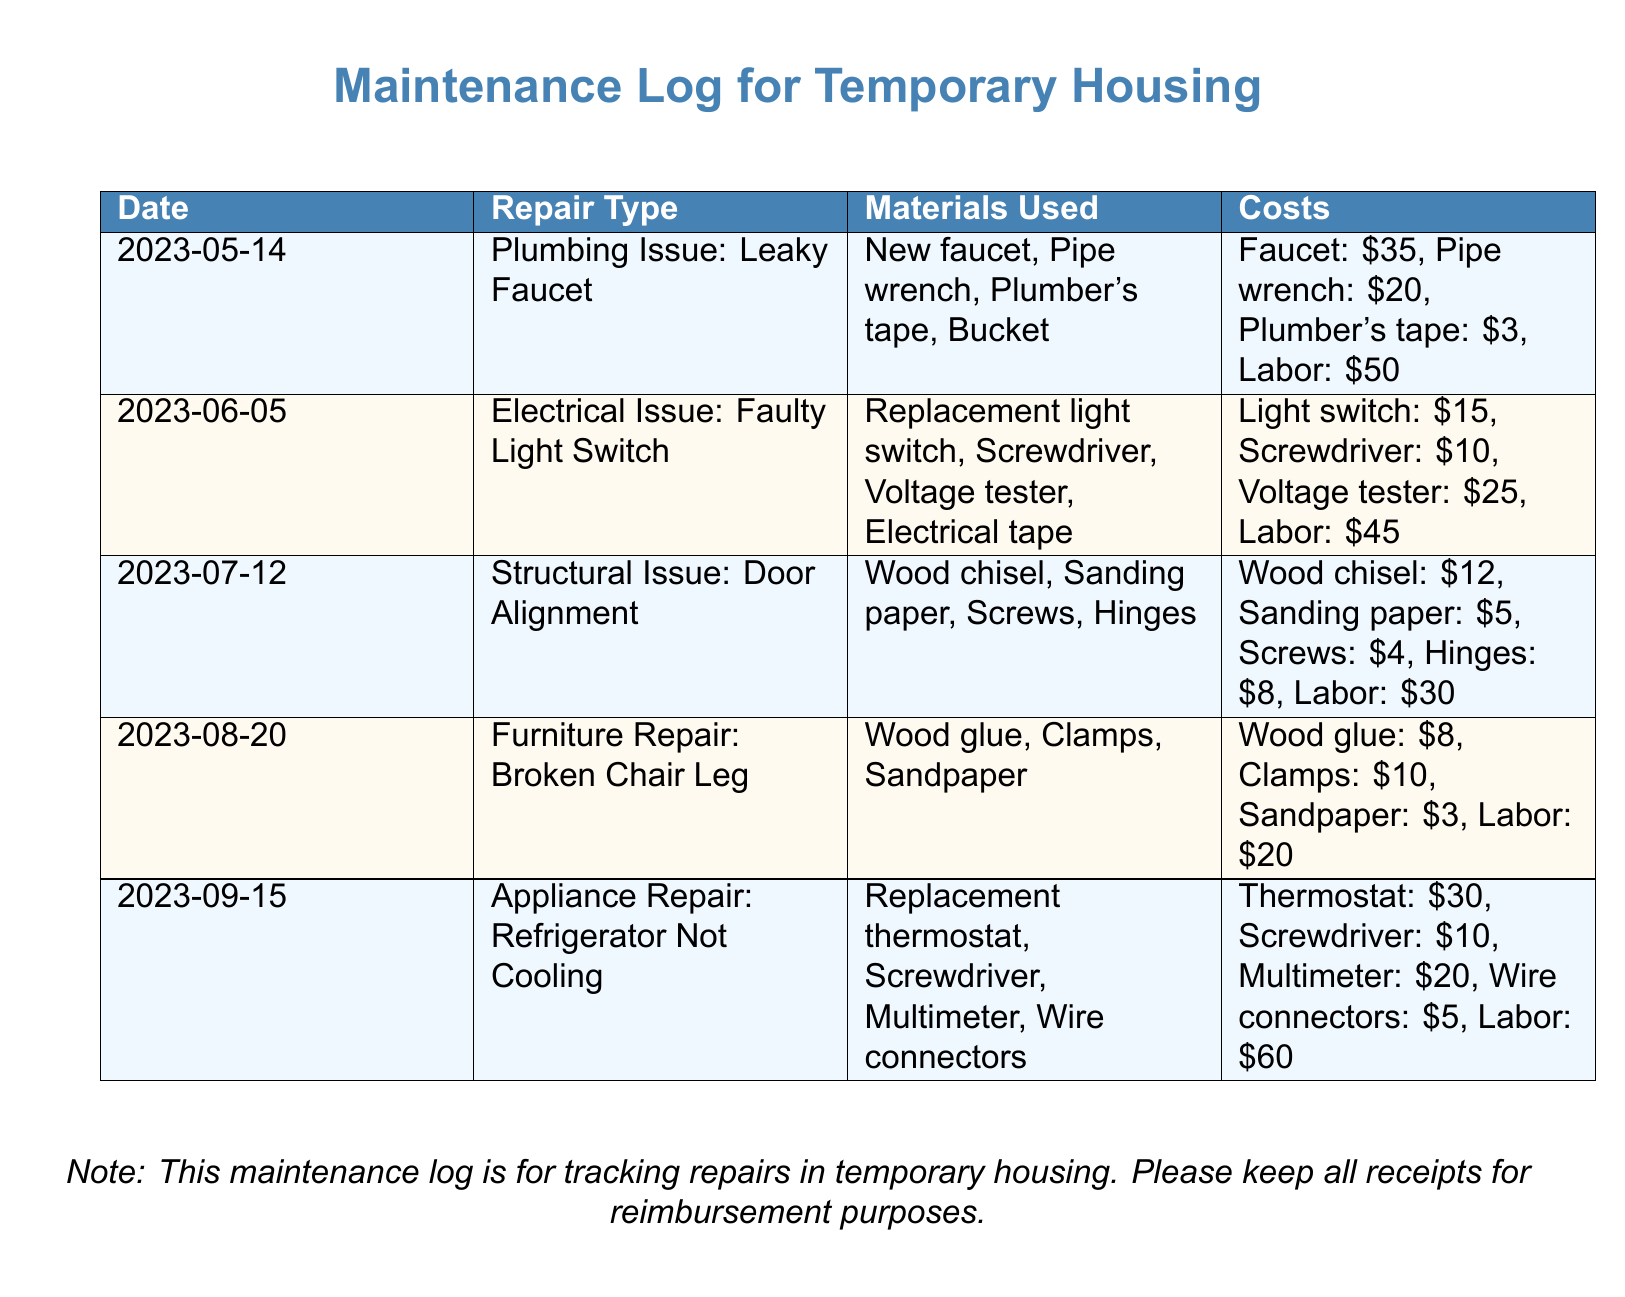What is the date of the plumbing repair? The date of the plumbing repair is listed in the document under the "Date" column, which shows "2023-05-14".
Answer: 2023-05-14 What is the repair type for the entry on June 5, 2023? The entry dated June 5, 2023, corresponds to "Electrical Issue: Faulty Light Switch" in the document.
Answer: Electrical Issue: Faulty Light Switch How much did the replacement thermostat cost? The document lists the cost for the thermostat in the "Costs" column under appliance repair, which is "$30".
Answer: $30 What materials were used for the furniture repair? The "Materials Used" column for the broken chair leg lists "Wood glue, Clamps, Sandpaper" as the materials used.
Answer: Wood glue, Clamps, Sandpaper What is the total cost of the structural issue repair on July 12, 2023? To find the total cost, we look under the "Costs" column for that date, which includes all materials and labor amounting to "$59".
Answer: $59 Which repair type had the highest labor cost? By examining the "Costs" section, the appliance repair for the refrigerator had the highest labor cost of "$60".
Answer: Appliance Repair: Refrigerator Not Cooling When was the last entry in the maintenance log? The last entry in the log corresponds to the date "2023-09-15," as listed in the "Date" column.
Answer: 2023-09-15 How much did the labor for the leaky faucet repair cost? The cost of labor for the leaky faucet repair is found in the "Costs" column, which indicates "$50" for labor.
Answer: $50 What was the repair type on August 20, 2023? The entry on August 20, 2023, details the repair type as "Furniture Repair: Broken Chair Leg" within the document.
Answer: Furniture Repair: Broken Chair Leg 